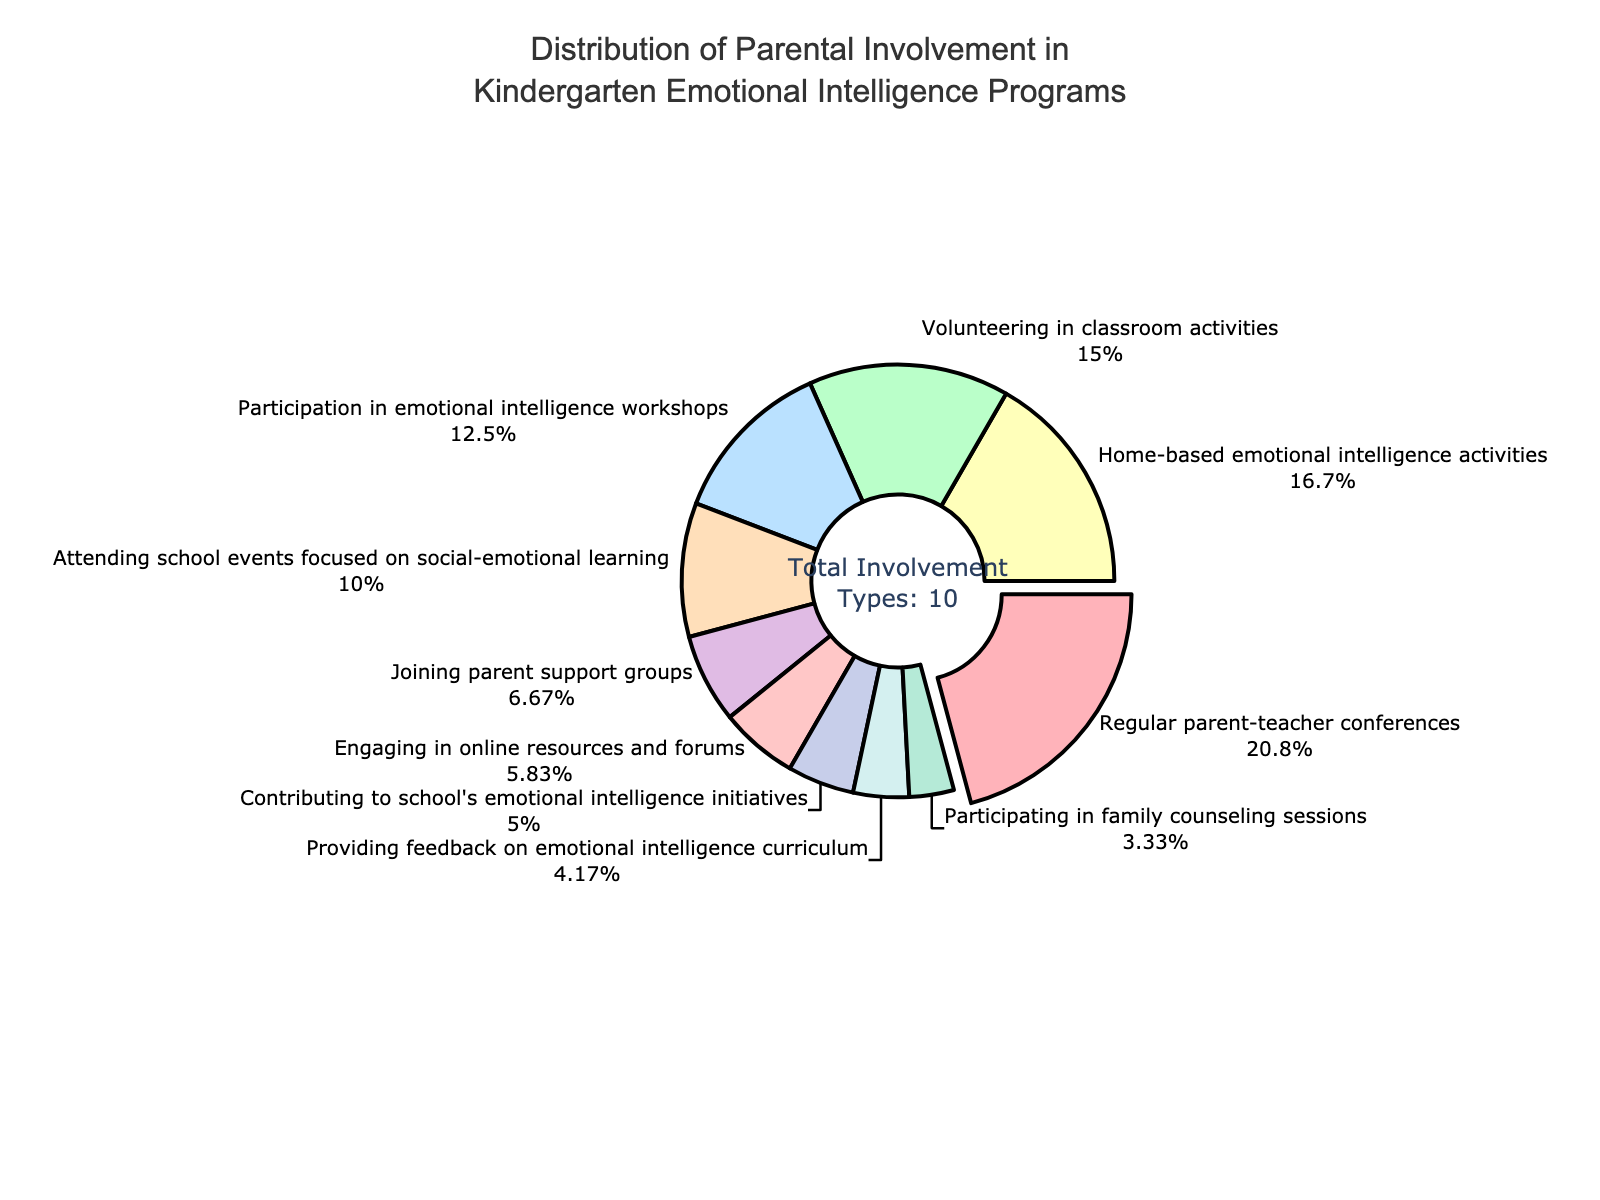Which type of parental involvement has the highest percentage? Identify the sections of the pie chart and find the one with the largest size. The largest segment is "Regular parent-teacher conferences" at 25%.
Answer: Regular parent-teacher conferences Which type of parental involvement has the least percentage? Look for the smallest segment in the pie chart, which is "Participating in family counseling sessions" at 4%.
Answer: Participating in family counseling sessions What is the combined percentage of "Home-based emotional intelligence activities" and "Participation in emotional intelligence workshops"? Add the percentages for both segments: 20% (Home-based emotional intelligence activities) + 15% (Participation in emotional intelligence workshops) = 35%.
Answer: 35% How much more is the percentage of "Volunteering in classroom activities" compared to "Providing feedback on emotional intelligence curriculum"? Subtract the percentage of providing feedback from volunteering: 18% - 5% = 13%.
Answer: 13% Which two types of parental involvement are closest in percentage? Compare the segments and find those with percentages that differ the least. "Joining parent support groups" (8%) and "Engaging in online resources and forums" (7%) are the closest.
Answer: Joining parent support groups and Engaging in online resources and forums What is the percentage difference between the highest and the lowest parental involvement types? Subtract the percentage of the smallest segment from the largest: 25% - 4% = 21%.
Answer: 21% What percentage of parents are involved in school events focused on social-emotional learning? Identify the segment labeled "Attending school events focused on social-emotional learning" to find its percentage, which is 12%.
Answer: 12% How many involvement types have a percentage greater than 10%? Count the segments with percentages above 10%: Regular parent-teacher conferences (25%), Volunteering in classroom activities (18%), Participation in emotional intelligence workshops (15%), and Home-based emotional intelligence activities (20%) total 4 types.
Answer: 4 Which involvement type in the pie chart corresponds to the color red? Identify the segment that is colored red, which is "Regular parent-teacher conferences".
Answer: Regular parent-teacher conferences 